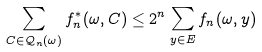<formula> <loc_0><loc_0><loc_500><loc_500>\sum _ { C \in \mathcal { Q } _ { n } ( \omega ) } f _ { n } ^ { * } ( \omega , C ) \leq 2 ^ { n } \sum _ { y \in E } f _ { n } ( \omega , y )</formula> 